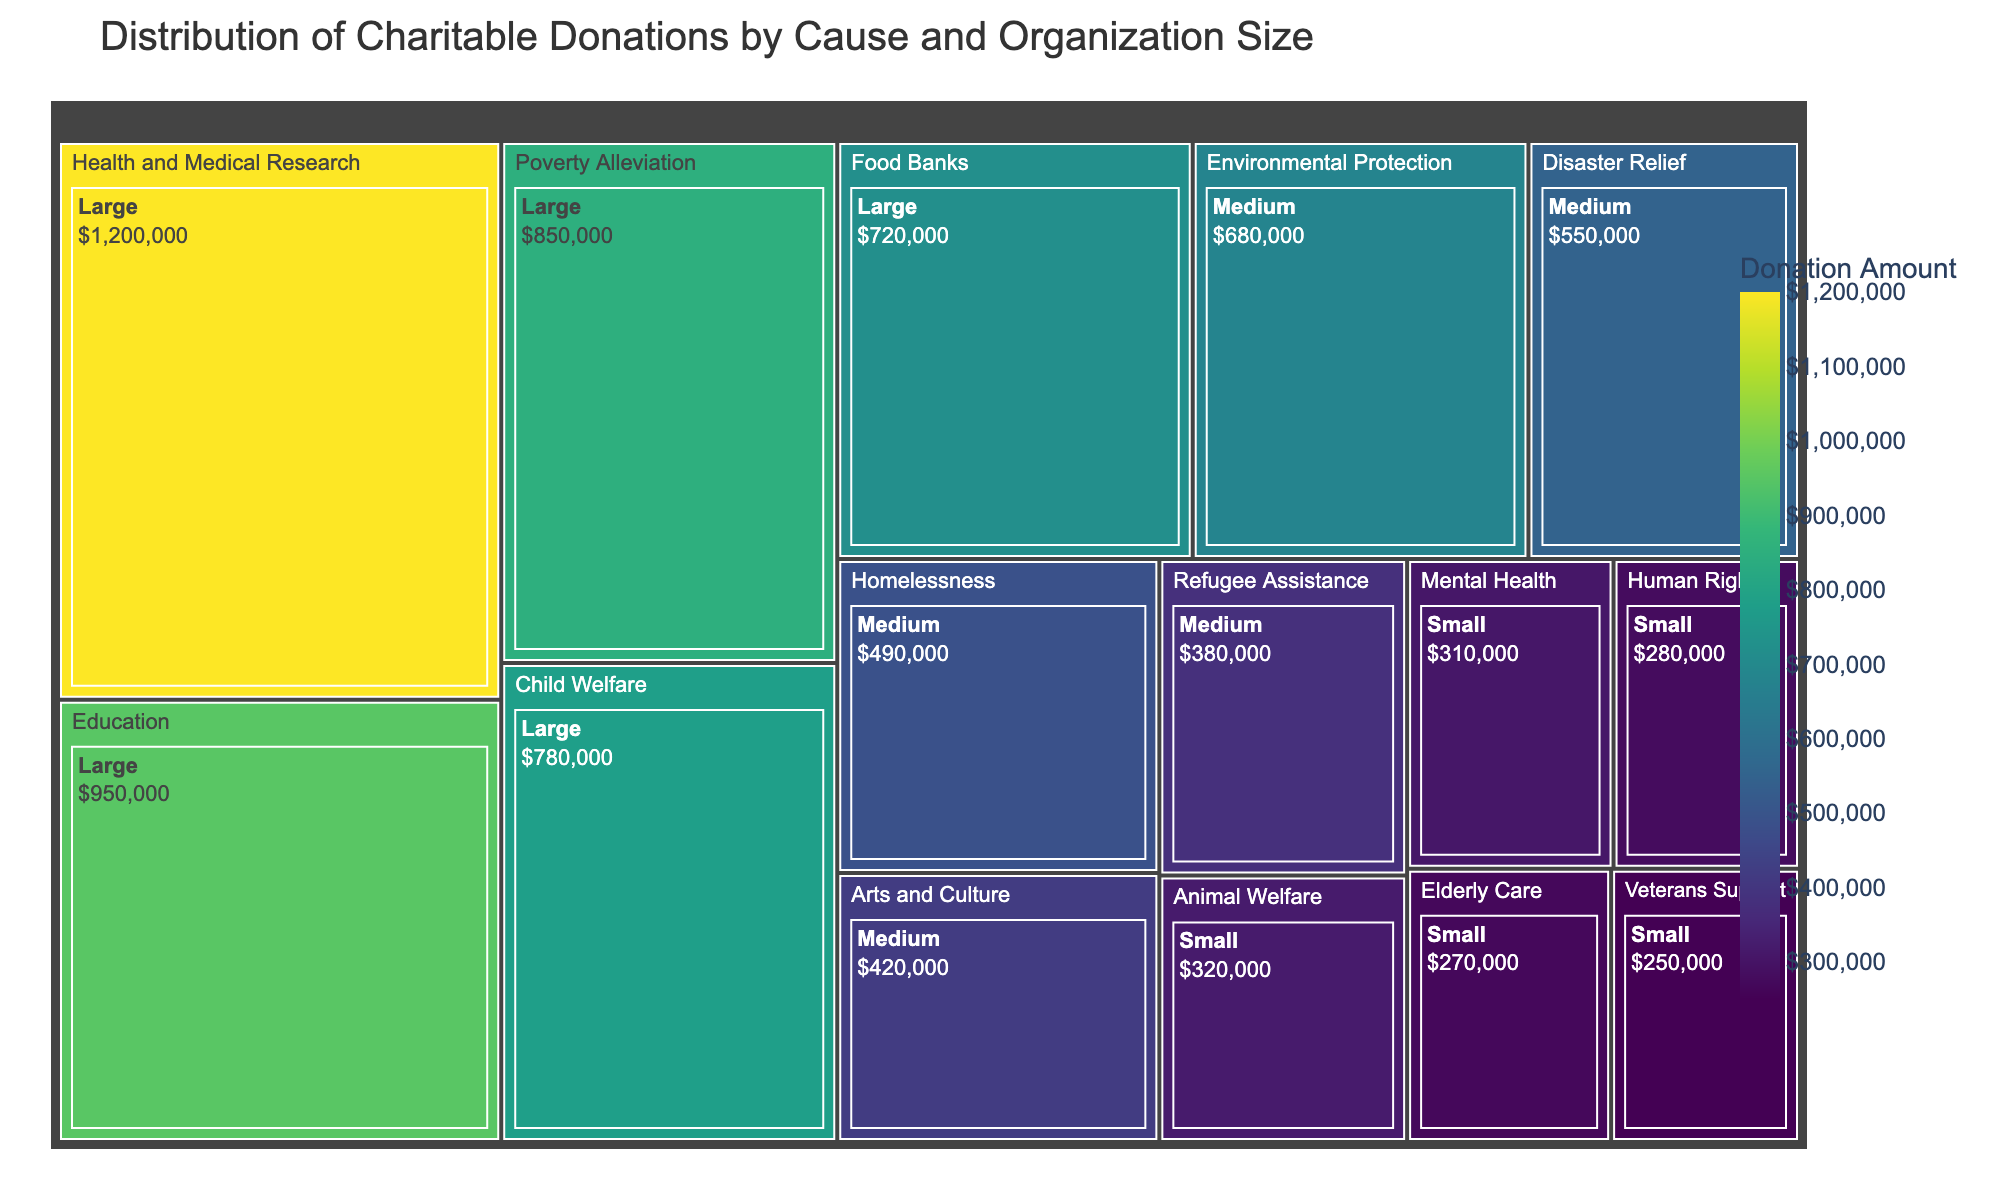What's the top cause by the donation amount? The top cause is the one with the highest donation amount, which is visually the largest rectangle. From the chart, Health and Medical Research, Large stands out.
Answer: Health and Medical Research What organization size receives the most donations in total? To determine this, sum the donation amounts for each organization size and compare them. Large organizations have high amounts for multiple causes (Health and Medical Research, Education, Poverty Alleviation, Child Welfare, Food Banks).
Answer: Large Which cause received the least donation amount? The smallest rectangle in the treemap represents the cause with the least donation amount. This is Human Rights, Small.
Answer: Human Rights How do donations to Medium-sized organizations compare to Small-sized organizations? Summing up donations for Medium-sized (Environmental Protection, Disaster Relief, Arts and Culture, Homelessness, Refugee Assistance) and Small-sized organizations (Animal Welfare, Human Rights, Veterans Support, Mental Health, Elderly Care), Medium totals more than Small.
Answer: Medium organizations receive more What percentage of donations does Health and Medical Research receive relative to the total? Sum all donations, then divide Health and Medical Research’s amount by this total and multiply by 100 to get the percentage. (1200000 / 8490000) * 100 = 14.13%.
Answer: ~14.13% Which cause among Large organizations receives the second highest amount of donations? Among Large organizations, Health and Medical Research is the highest, and Education is visually the next largest rectangle.
Answer: Education Compare the total donations for Environmental Protection and Child Welfare. Sum Environmental Protection (680000) and Child Welfare (780000) and determine which is larger. Child Welfare receives more.
Answer: Child Welfare How do donations for Mental Health compare to those for Elderly Care? Both belong to the Small organization size. Compare 310000 (Mental Health) to 270000 (Elderly Care).
Answer: Mental Health receives more What’s the difference between donations for Disability Support (if it exists) and Human Rights? Check if Disability Support is present (it’s not) versus Human Rights (280000). Since there's no Disability Support, the difference is the donation amount for Human Rights.
Answer: 280000 Which cause receives more donations: Homelessness or Food Banks? Compare the donation amounts for Homelessness (490000) and Food Banks (720000).
Answer: Food Banks 